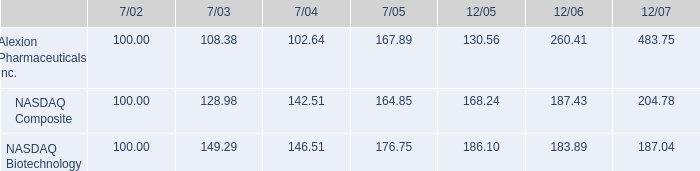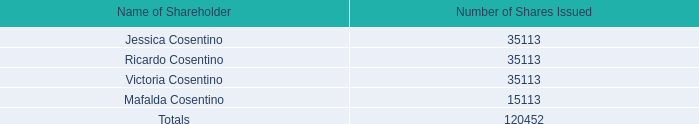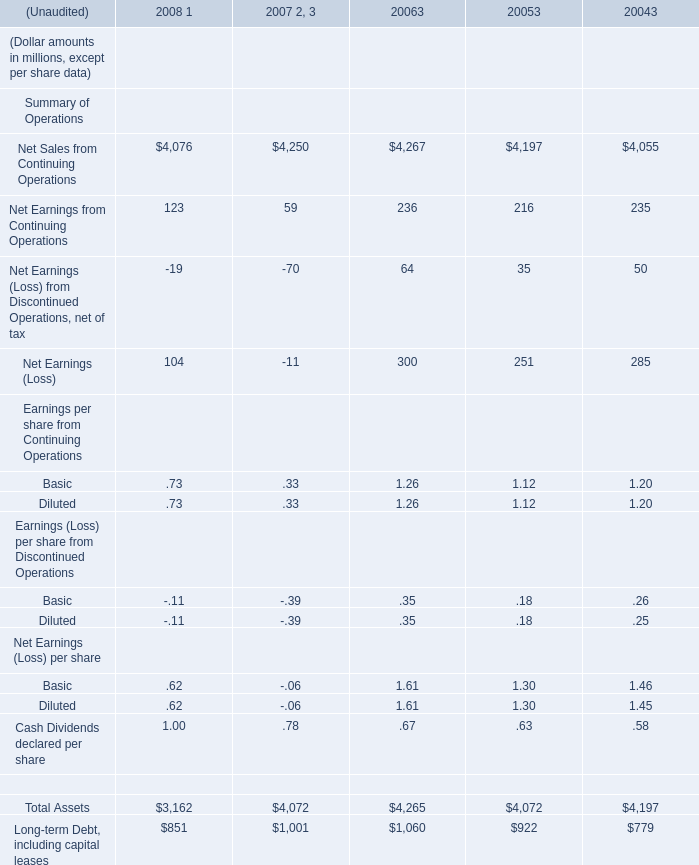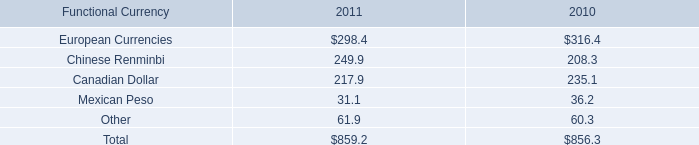In which year is Net Earnings (Loss) from Discontinued Operations, net of tax positive? 
Answer: 2004 2005 2006. 